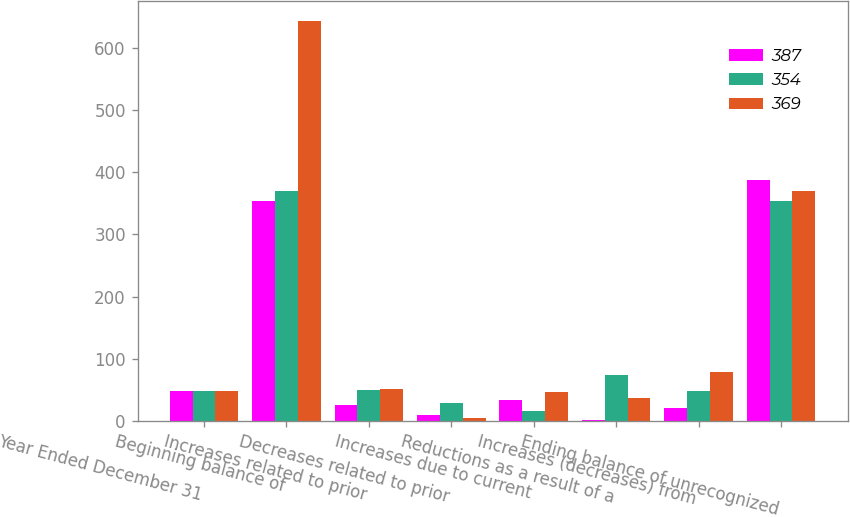<chart> <loc_0><loc_0><loc_500><loc_500><stacked_bar_chart><ecel><fcel>Year Ended December 31<fcel>Beginning balance of<fcel>Increases related to prior<fcel>Decreases related to prior<fcel>Increases due to current<fcel>Reductions as a result of a<fcel>Increases (decreases) from<fcel>Ending balance of unrecognized<nl><fcel>387<fcel>48<fcel>354<fcel>26<fcel>10<fcel>33<fcel>1<fcel>21<fcel>387<nl><fcel>354<fcel>48<fcel>369<fcel>49<fcel>28<fcel>16<fcel>73<fcel>48<fcel>354<nl><fcel>369<fcel>48<fcel>643<fcel>52<fcel>4<fcel>47<fcel>36<fcel>79<fcel>369<nl></chart> 